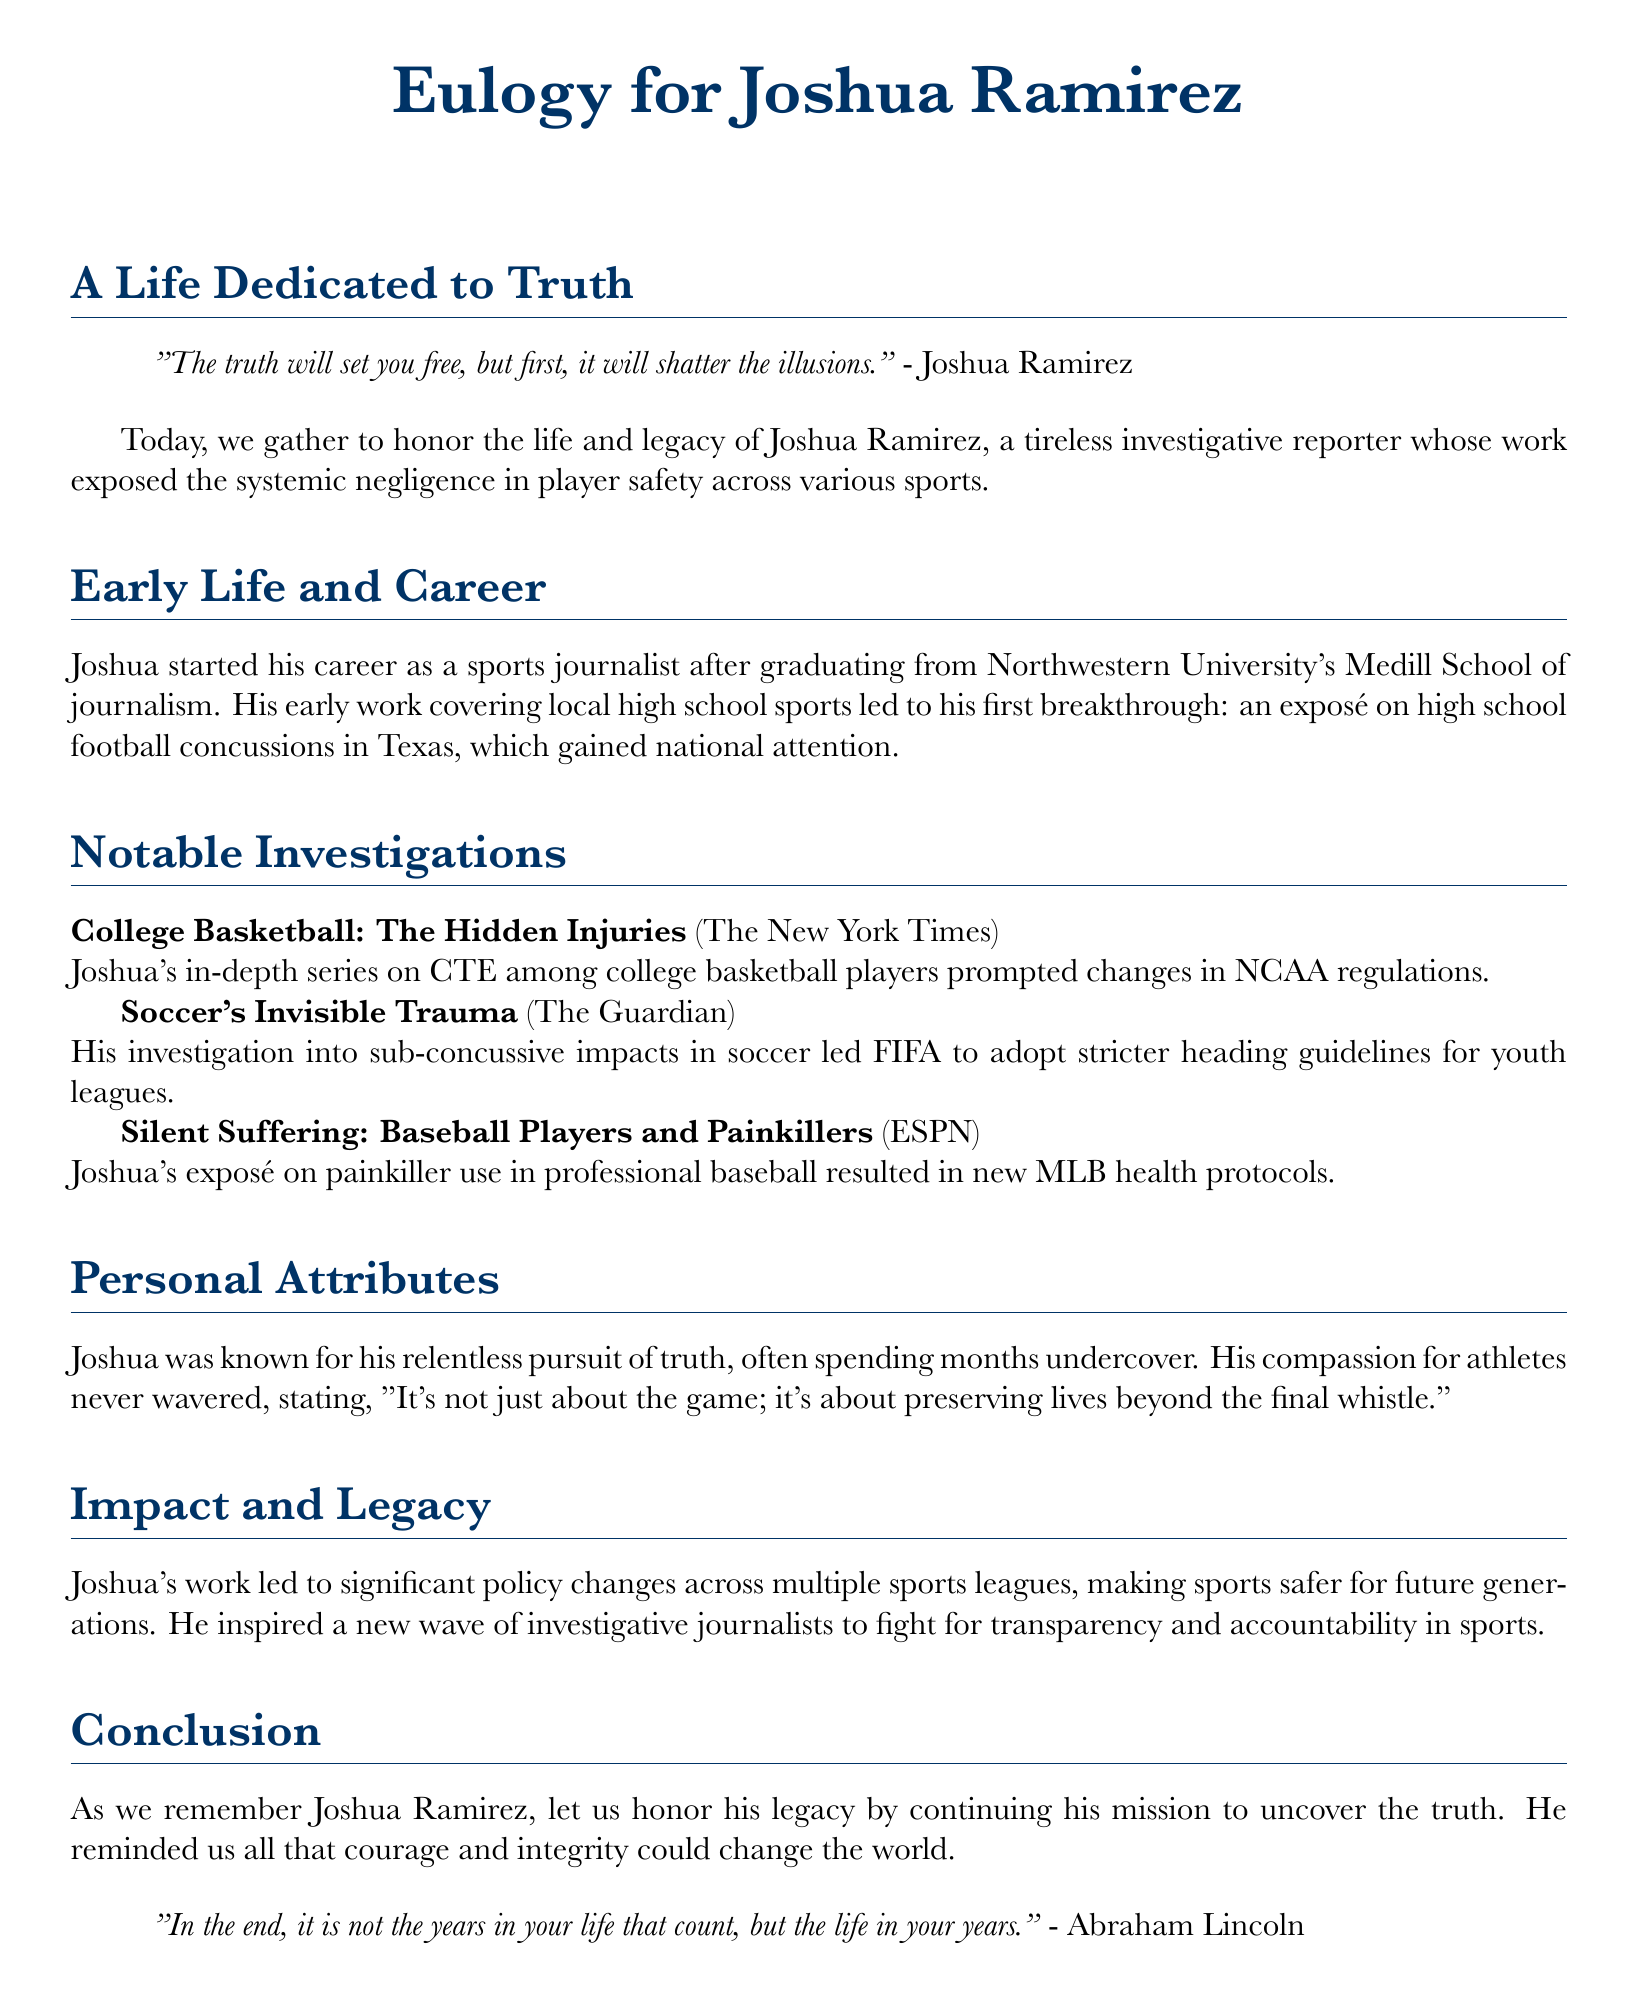What is the full name of the journalist being honored? The full name of the journalist is mentioned in the title as Joshua Ramirez.
Answer: Joshua Ramirez Where did Joshua graduate from? The document states that he graduated from Northwestern University's Medill School of journalism.
Answer: Northwestern University Which sports organization changed its regulations due to Joshua's investigation on CTE? The investigation led to changes in NCAA regulations.
Answer: NCAA What was the title of Joshua's exposé on painkiller use in professional baseball? The exposé is titled "Silent Suffering: Baseball Players and Painkillers."
Answer: Silent Suffering: Baseball Players and Painkillers What was Joshua's first major breakthrough story? His first breakthrough was an exposé on high school football concussions in Texas.
Answer: High school football concussions in Texas What type of journalism did Joshua primarily focus on? The document highlights that he focused on investigative journalism.
Answer: Investigative journalism What quote by Joshua emphasizes the importance of his work beyond the sport? He stated, "It's not just about the game; it's about preserving lives beyond the final whistle."
Answer: "It's not just about the game; it's about preserving lives beyond the final whistle." What legacy did Joshua leave for future journalists? His work inspired a new wave of investigative journalists to fight for transparency and accountability in sports.
Answer: Inspired a new wave of investigative journalists 